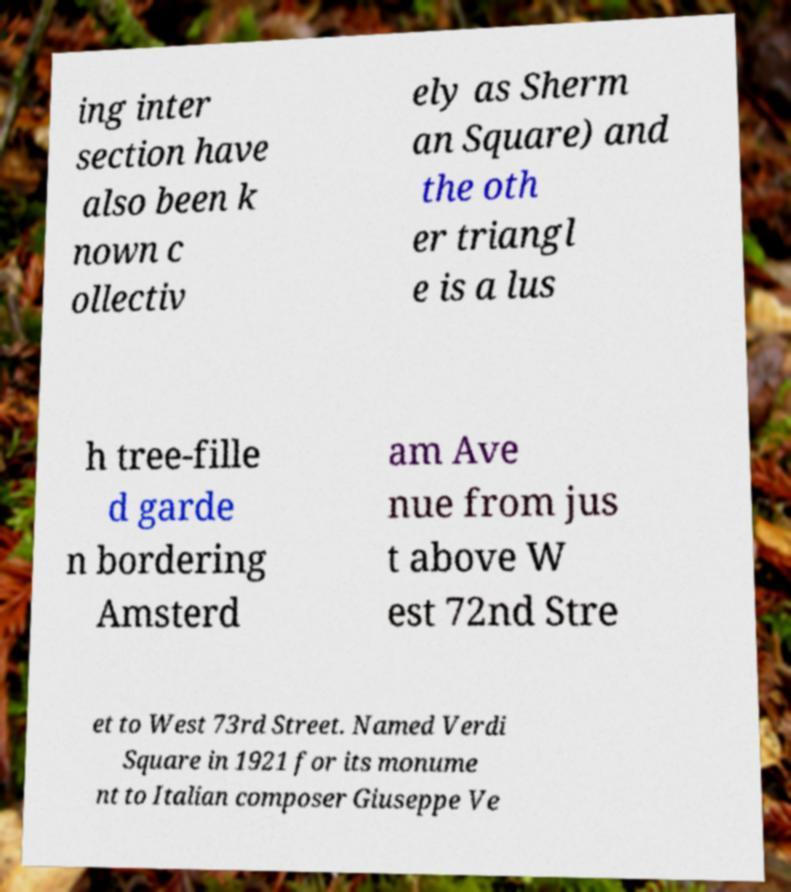What messages or text are displayed in this image? I need them in a readable, typed format. ing inter section have also been k nown c ollectiv ely as Sherm an Square) and the oth er triangl e is a lus h tree-fille d garde n bordering Amsterd am Ave nue from jus t above W est 72nd Stre et to West 73rd Street. Named Verdi Square in 1921 for its monume nt to Italian composer Giuseppe Ve 